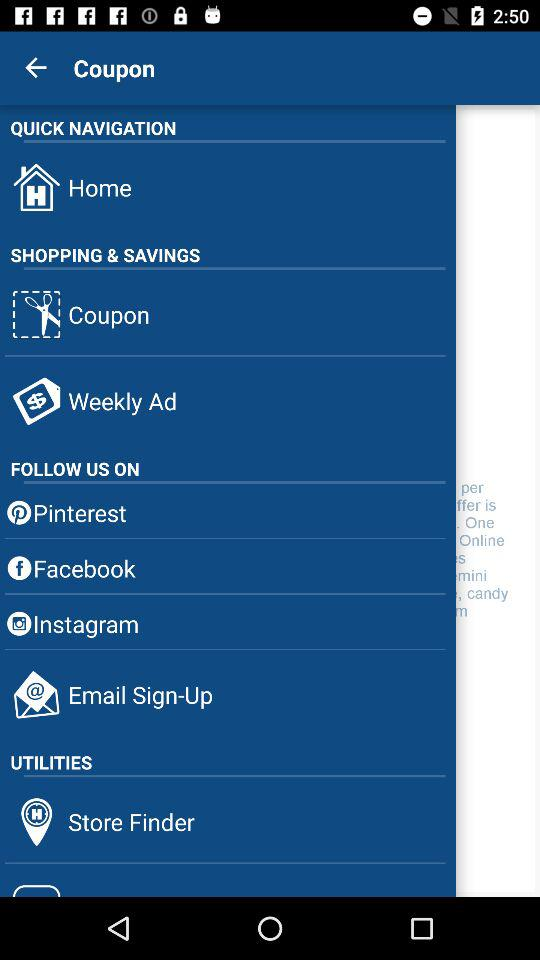How many items are there in the UTILITIES section?
Answer the question using a single word or phrase. 2 